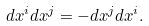<formula> <loc_0><loc_0><loc_500><loc_500>d x ^ { i } d x ^ { j } = - d x ^ { j } d x ^ { i } .</formula> 